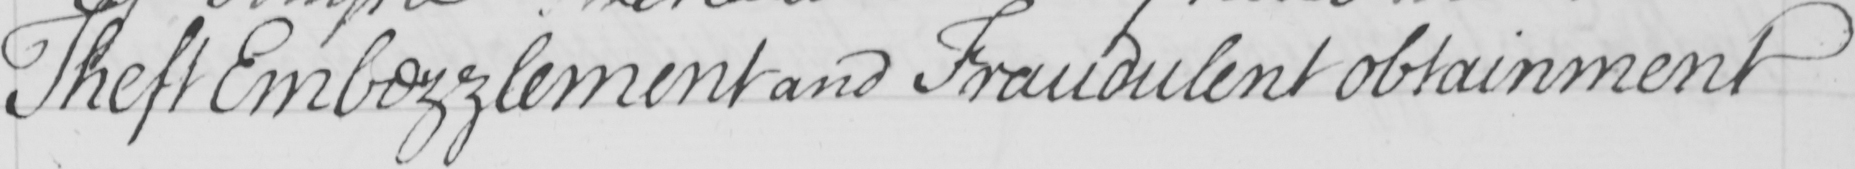Can you read and transcribe this handwriting? Theft Embezzlement and Fraudulent obtainment 